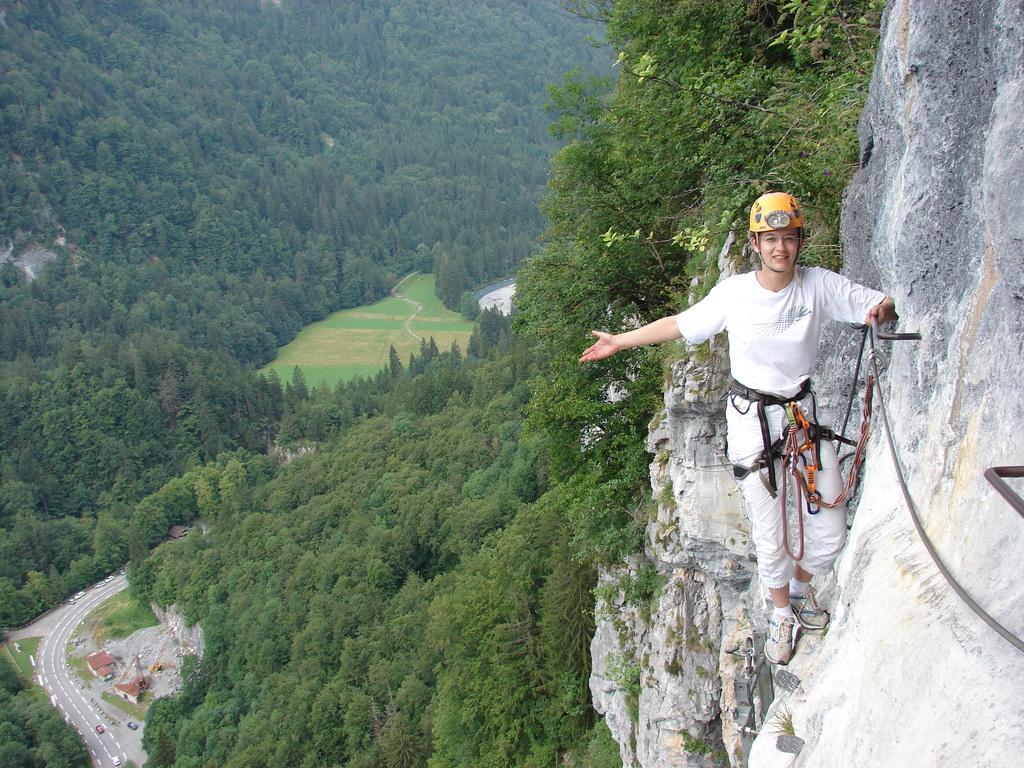Can you describe this image briefly? In this image I can see a woman is standing, I can see she is wearing white colour dress, white shoes, yellow helmet and I can see she is holding a rope. In the background I can see number of trees and a road. 